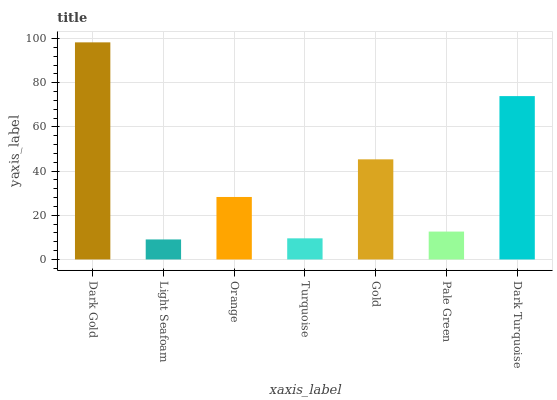Is Light Seafoam the minimum?
Answer yes or no. Yes. Is Dark Gold the maximum?
Answer yes or no. Yes. Is Orange the minimum?
Answer yes or no. No. Is Orange the maximum?
Answer yes or no. No. Is Orange greater than Light Seafoam?
Answer yes or no. Yes. Is Light Seafoam less than Orange?
Answer yes or no. Yes. Is Light Seafoam greater than Orange?
Answer yes or no. No. Is Orange less than Light Seafoam?
Answer yes or no. No. Is Orange the high median?
Answer yes or no. Yes. Is Orange the low median?
Answer yes or no. Yes. Is Dark Turquoise the high median?
Answer yes or no. No. Is Dark Turquoise the low median?
Answer yes or no. No. 